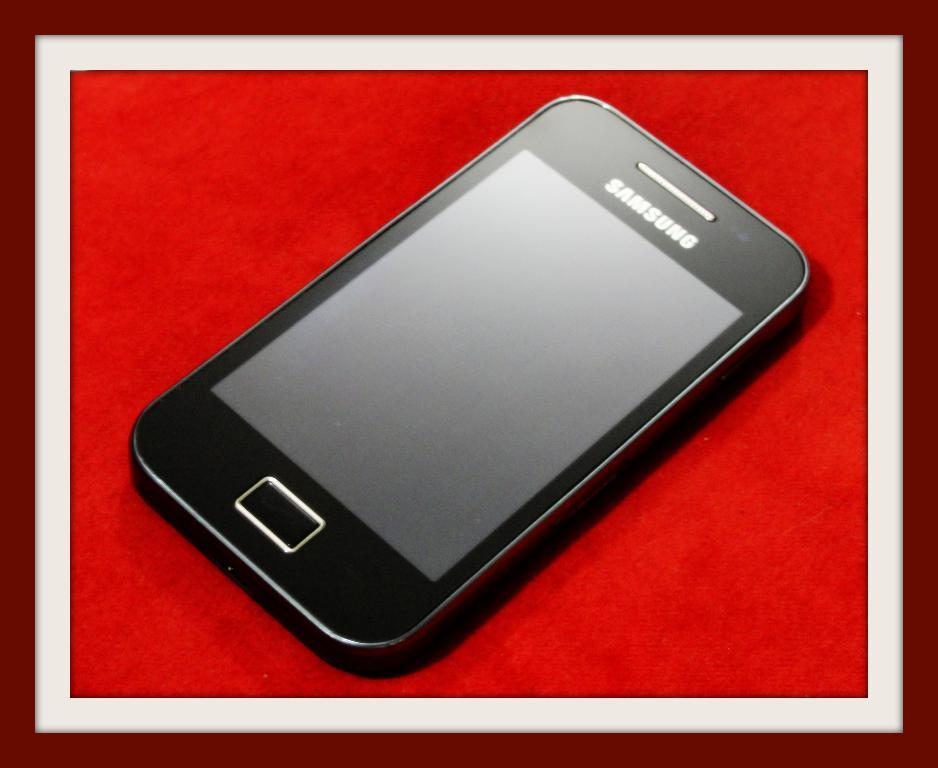<image>
Render a clear and concise summary of the photo. Black Samsung phone with a red background in the back. 